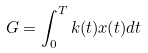Convert formula to latex. <formula><loc_0><loc_0><loc_500><loc_500>G = \int _ { 0 } ^ { T } k ( t ) x ( t ) d t</formula> 